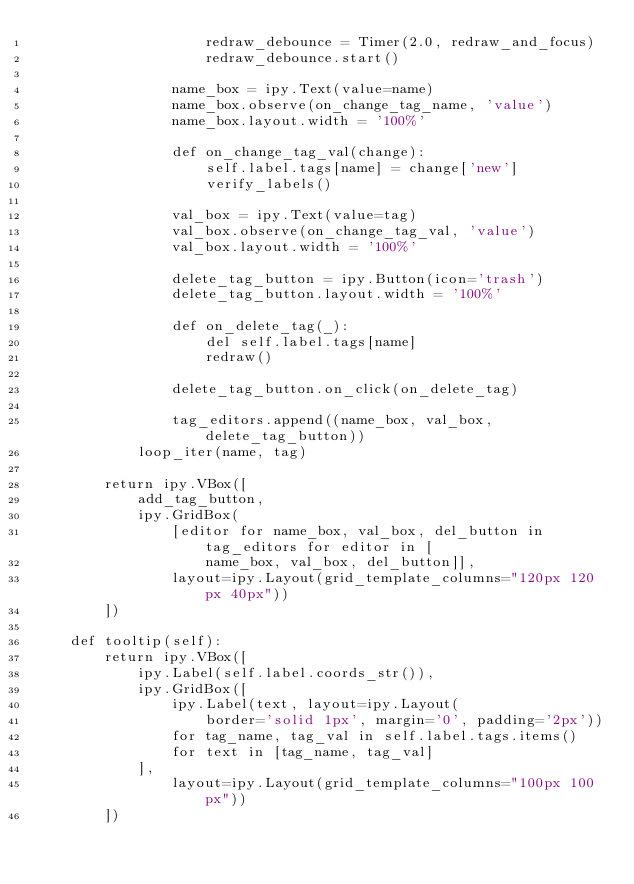<code> <loc_0><loc_0><loc_500><loc_500><_Python_>                    redraw_debounce = Timer(2.0, redraw_and_focus)
                    redraw_debounce.start()

                name_box = ipy.Text(value=name)
                name_box.observe(on_change_tag_name, 'value')
                name_box.layout.width = '100%'

                def on_change_tag_val(change):
                    self.label.tags[name] = change['new']
                    verify_labels()

                val_box = ipy.Text(value=tag)
                val_box.observe(on_change_tag_val, 'value')
                val_box.layout.width = '100%'

                delete_tag_button = ipy.Button(icon='trash')
                delete_tag_button.layout.width = '100%'

                def on_delete_tag(_):
                    del self.label.tags[name]
                    redraw()

                delete_tag_button.on_click(on_delete_tag)

                tag_editors.append((name_box, val_box, delete_tag_button))
            loop_iter(name, tag)

        return ipy.VBox([
            add_tag_button,
            ipy.GridBox(
                [editor for name_box, val_box, del_button in tag_editors for editor in [
                    name_box, val_box, del_button]],
                layout=ipy.Layout(grid_template_columns="120px 120px 40px"))
        ])

    def tooltip(self):
        return ipy.VBox([
            ipy.Label(self.label.coords_str()),
            ipy.GridBox([
                ipy.Label(text, layout=ipy.Layout(
                    border='solid 1px', margin='0', padding='2px'))
                for tag_name, tag_val in self.label.tags.items()
                for text in [tag_name, tag_val]
            ],
                layout=ipy.Layout(grid_template_columns="100px 100px"))
        ])
</code> 